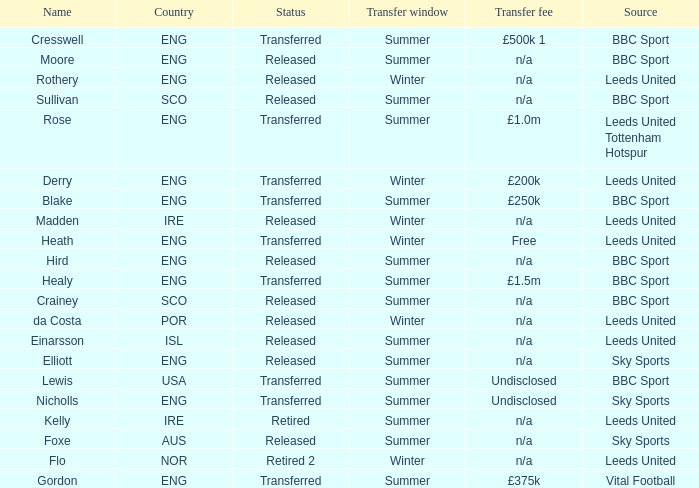What was the transfer fee for the summer transfer involving the SCO named Crainey? N/a. 